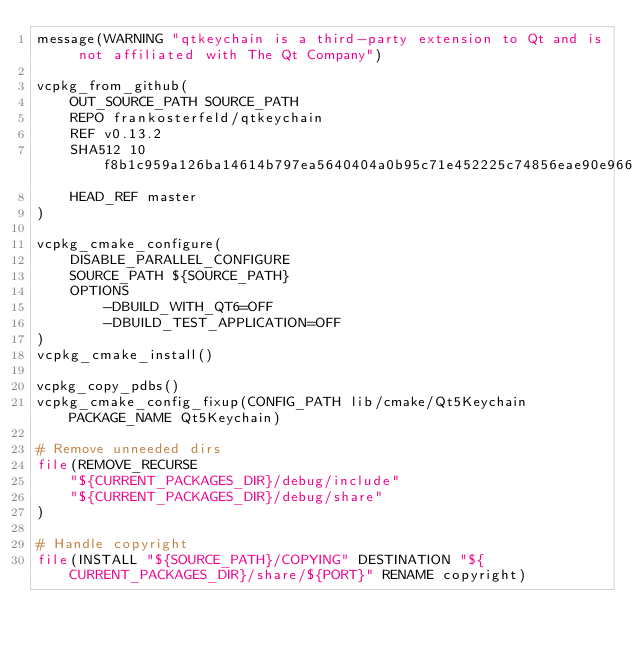<code> <loc_0><loc_0><loc_500><loc_500><_CMake_>message(WARNING "qtkeychain is a third-party extension to Qt and is not affiliated with The Qt Company")

vcpkg_from_github(
    OUT_SOURCE_PATH SOURCE_PATH
    REPO frankosterfeld/qtkeychain
    REF v0.13.2
    SHA512 10f8b1c959a126ba14614b797ea5640404a0b95c71e452225c74856eae90e966aac581ca393508a2106033c3d5ad70427ea6f7ef3f2997eddf6d09a7b4fa26eb
    HEAD_REF master
)

vcpkg_cmake_configure(
    DISABLE_PARALLEL_CONFIGURE
    SOURCE_PATH ${SOURCE_PATH}
    OPTIONS
        -DBUILD_WITH_QT6=OFF
        -DBUILD_TEST_APPLICATION=OFF
)
vcpkg_cmake_install()

vcpkg_copy_pdbs()
vcpkg_cmake_config_fixup(CONFIG_PATH lib/cmake/Qt5Keychain PACKAGE_NAME Qt5Keychain)

# Remove unneeded dirs
file(REMOVE_RECURSE
    "${CURRENT_PACKAGES_DIR}/debug/include"
    "${CURRENT_PACKAGES_DIR}/debug/share"
)

# Handle copyright
file(INSTALL "${SOURCE_PATH}/COPYING" DESTINATION "${CURRENT_PACKAGES_DIR}/share/${PORT}" RENAME copyright)
</code> 